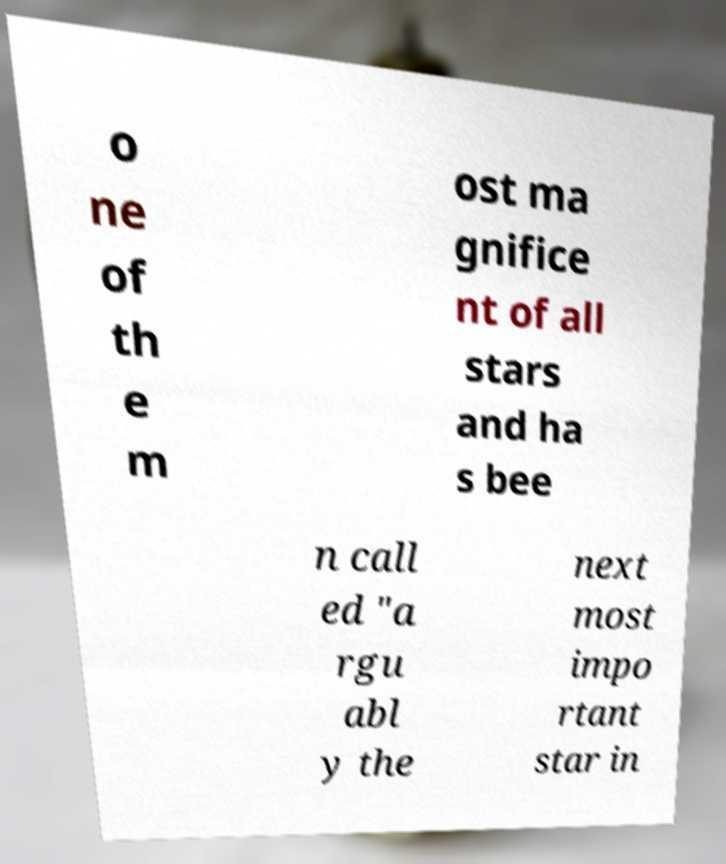Could you assist in decoding the text presented in this image and type it out clearly? o ne of th e m ost ma gnifice nt of all stars and ha s bee n call ed "a rgu abl y the next most impo rtant star in 